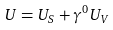Convert formula to latex. <formula><loc_0><loc_0><loc_500><loc_500>U = U _ { S } + \gamma ^ { 0 } U _ { V }</formula> 